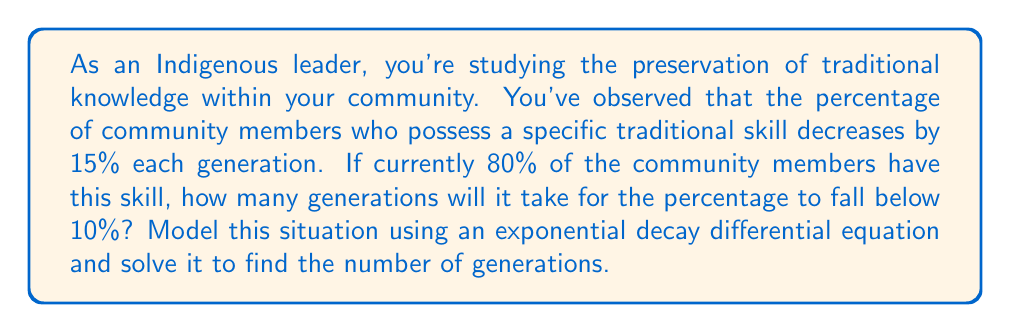What is the answer to this math problem? Let's approach this problem step-by-step using a first-order differential equation:

1) Let $P(t)$ be the percentage of community members with the skill at generation $t$.

2) The rate of change is proportional to the current percentage, with a decay rate of 15% per generation. This can be modeled as:

   $$\frac{dP}{dt} = -0.15P$$

3) This is a separable differential equation. We can solve it as follows:

   $$\int \frac{dP}{P} = \int -0.15 dt$$

   $$\ln|P| = -0.15t + C$$

   $$P(t) = Ae^{-0.15t}$$

   where $A$ is a constant determined by the initial condition.

4) Given the initial condition $P(0) = 80$, we can find $A$:

   $$80 = Ae^{-0.15(0)}$$
   $$A = 80$$

5) So our solution is:

   $$P(t) = 80e^{-0.15t}$$

6) We want to find when $P(t) < 10$. Let's solve this inequality:

   $$80e^{-0.15t} < 10$$
   $$e^{-0.15t} < \frac{1}{8}$$
   $$-0.15t < \ln(\frac{1}{8})$$
   $$t > -\frac{\ln(\frac{1}{8})}{0.15} \approx 13.82$$

7) Since we're dealing with generations, we need to round up to the next whole number.

Therefore, it will take 14 generations for the percentage to fall below 10%.
Answer: 14 generations 